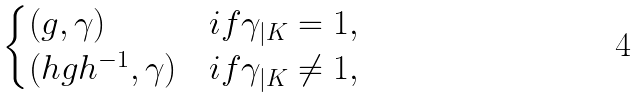<formula> <loc_0><loc_0><loc_500><loc_500>\begin{cases} ( g , \gamma ) & i f \gamma _ { | K } = 1 , \\ ( h g h ^ { - 1 } , \gamma ) & i f \gamma _ { | K } \not = 1 , \end{cases}</formula> 